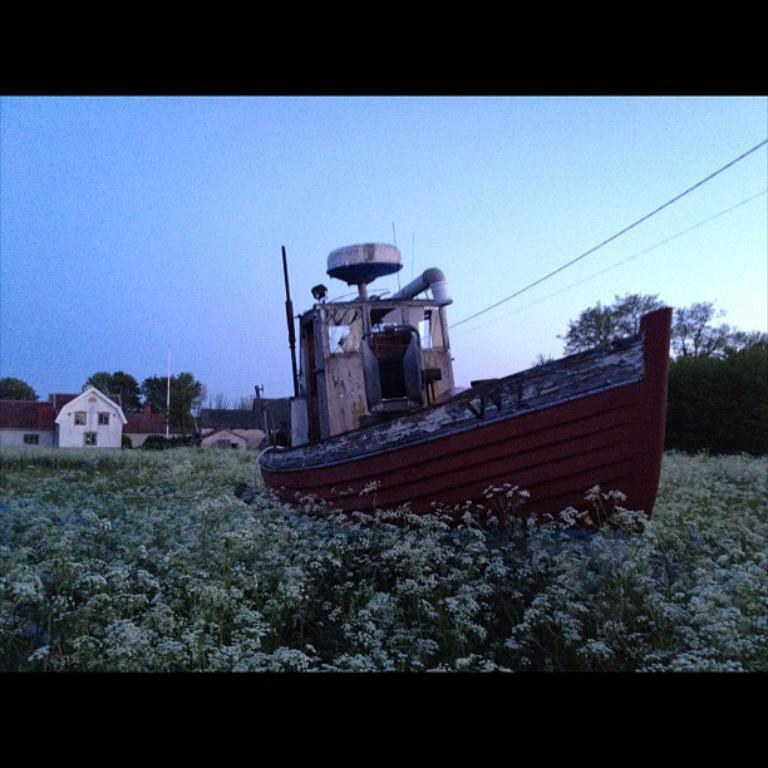What is the main object in the field in the image? There is a boat in the field in the image. What can be seen around the boat? There are flowers and plants around the boat. What is visible in the background of the image? There are houses, poles, cables, and trees in the background. What type of tax is being discussed by the people in the boat? There are no people in the boat, and no tax is being discussed in the image. Can you see any smoke coming from the boat in the image? There is no smoke visible in the image; the boat is stationary in the field. 